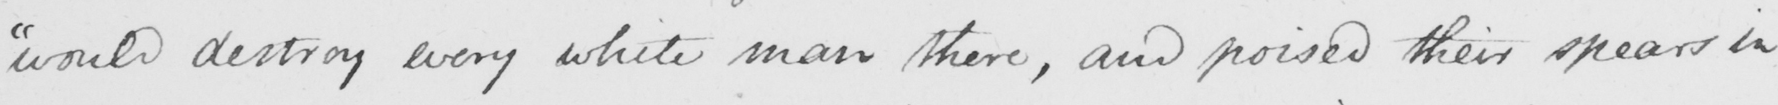Transcribe the text shown in this historical manuscript line. " would destroy every white man there , and poised their spears in 